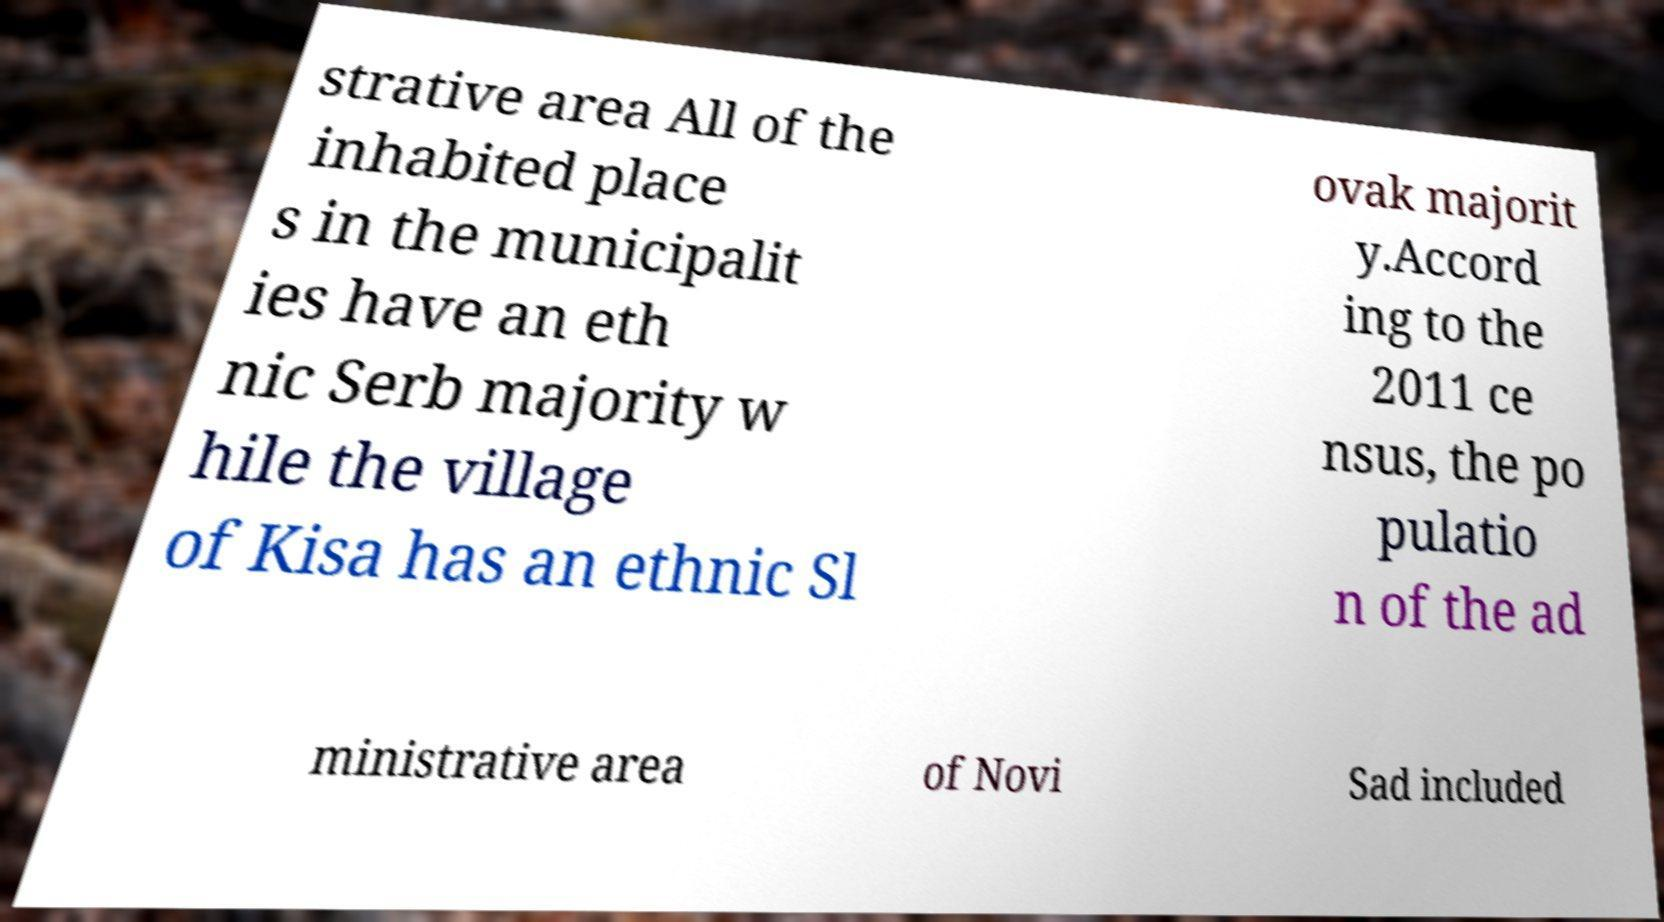There's text embedded in this image that I need extracted. Can you transcribe it verbatim? strative area All of the inhabited place s in the municipalit ies have an eth nic Serb majority w hile the village of Kisa has an ethnic Sl ovak majorit y.Accord ing to the 2011 ce nsus, the po pulatio n of the ad ministrative area of Novi Sad included 